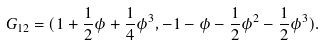<formula> <loc_0><loc_0><loc_500><loc_500>G _ { 1 2 } = ( 1 + \frac { 1 } { 2 } \phi + \frac { 1 } { 4 } \phi ^ { 3 } , - 1 - \phi - \frac { 1 } { 2 } \phi ^ { 2 } - \frac { 1 } { 2 } \phi ^ { 3 } ) .</formula> 